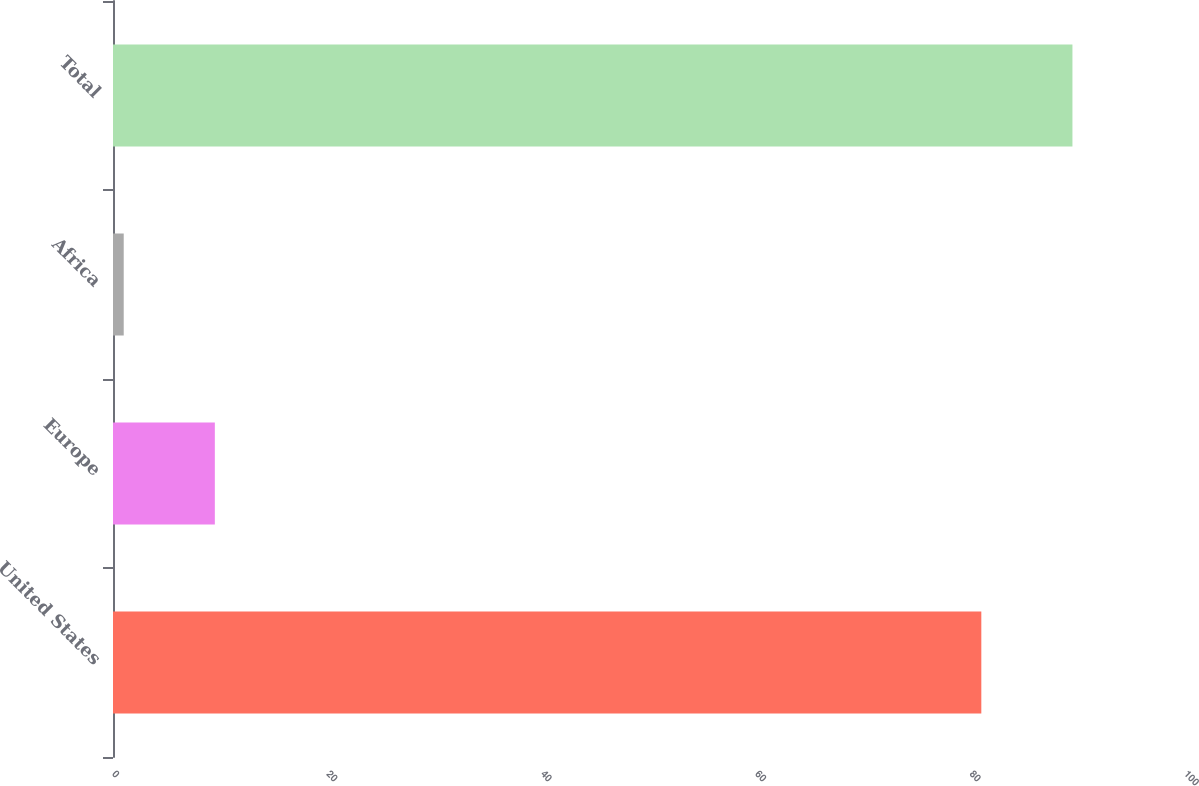<chart> <loc_0><loc_0><loc_500><loc_500><bar_chart><fcel>United States<fcel>Europe<fcel>Africa<fcel>Total<nl><fcel>81<fcel>9.5<fcel>1<fcel>89.5<nl></chart> 